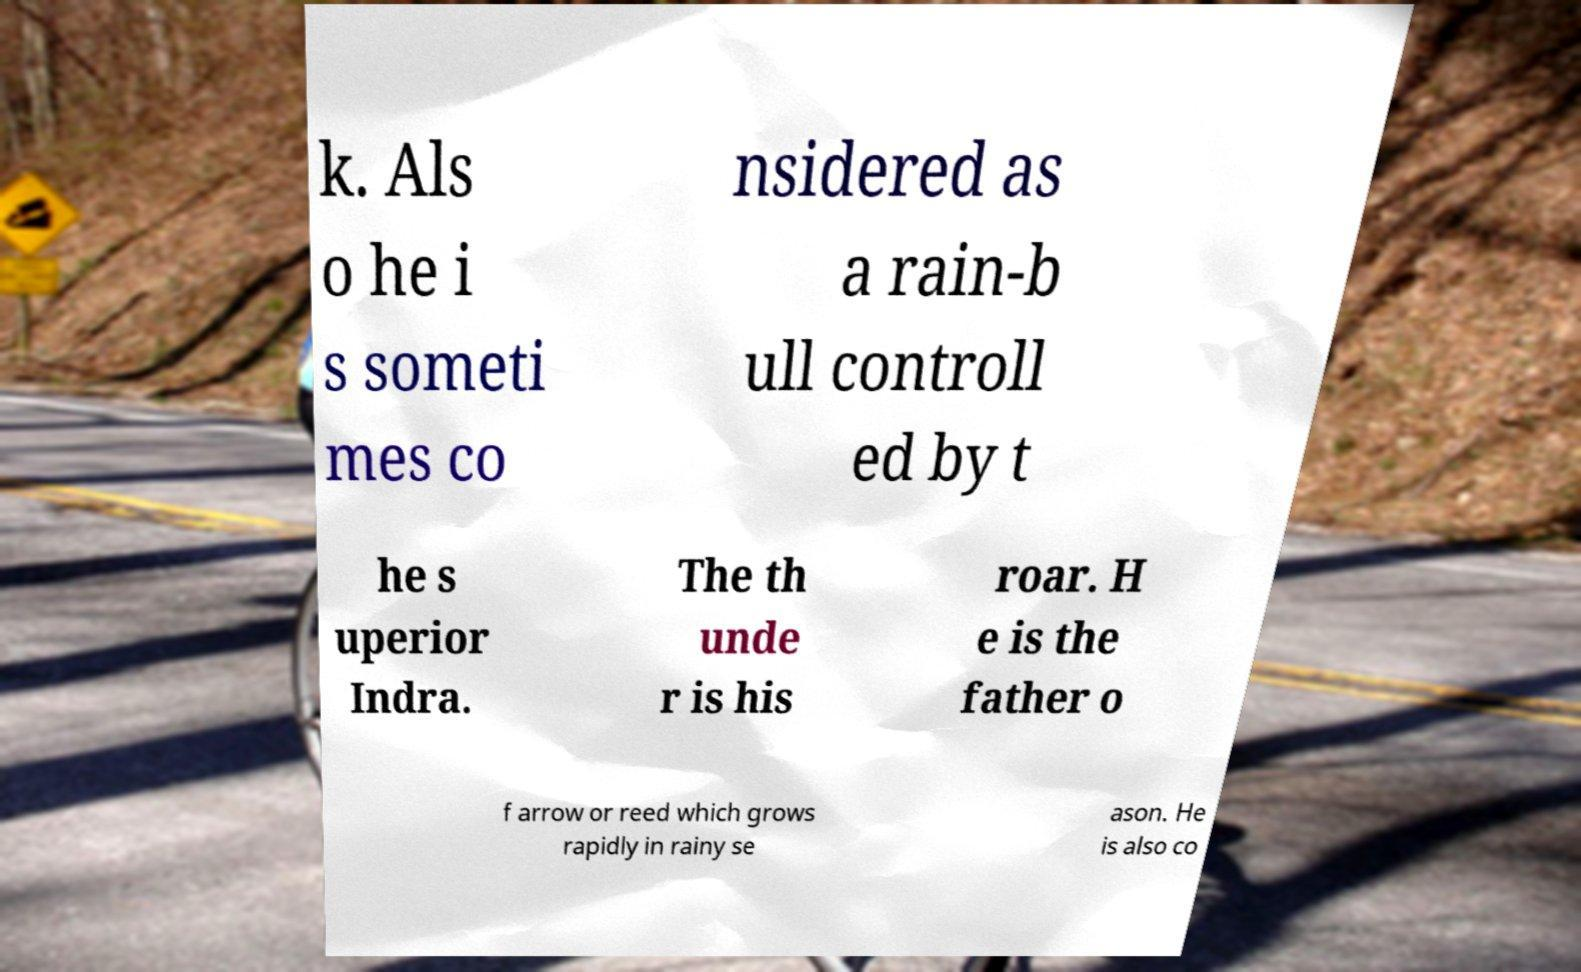Please identify and transcribe the text found in this image. k. Als o he i s someti mes co nsidered as a rain-b ull controll ed by t he s uperior Indra. The th unde r is his roar. H e is the father o f arrow or reed which grows rapidly in rainy se ason. He is also co 